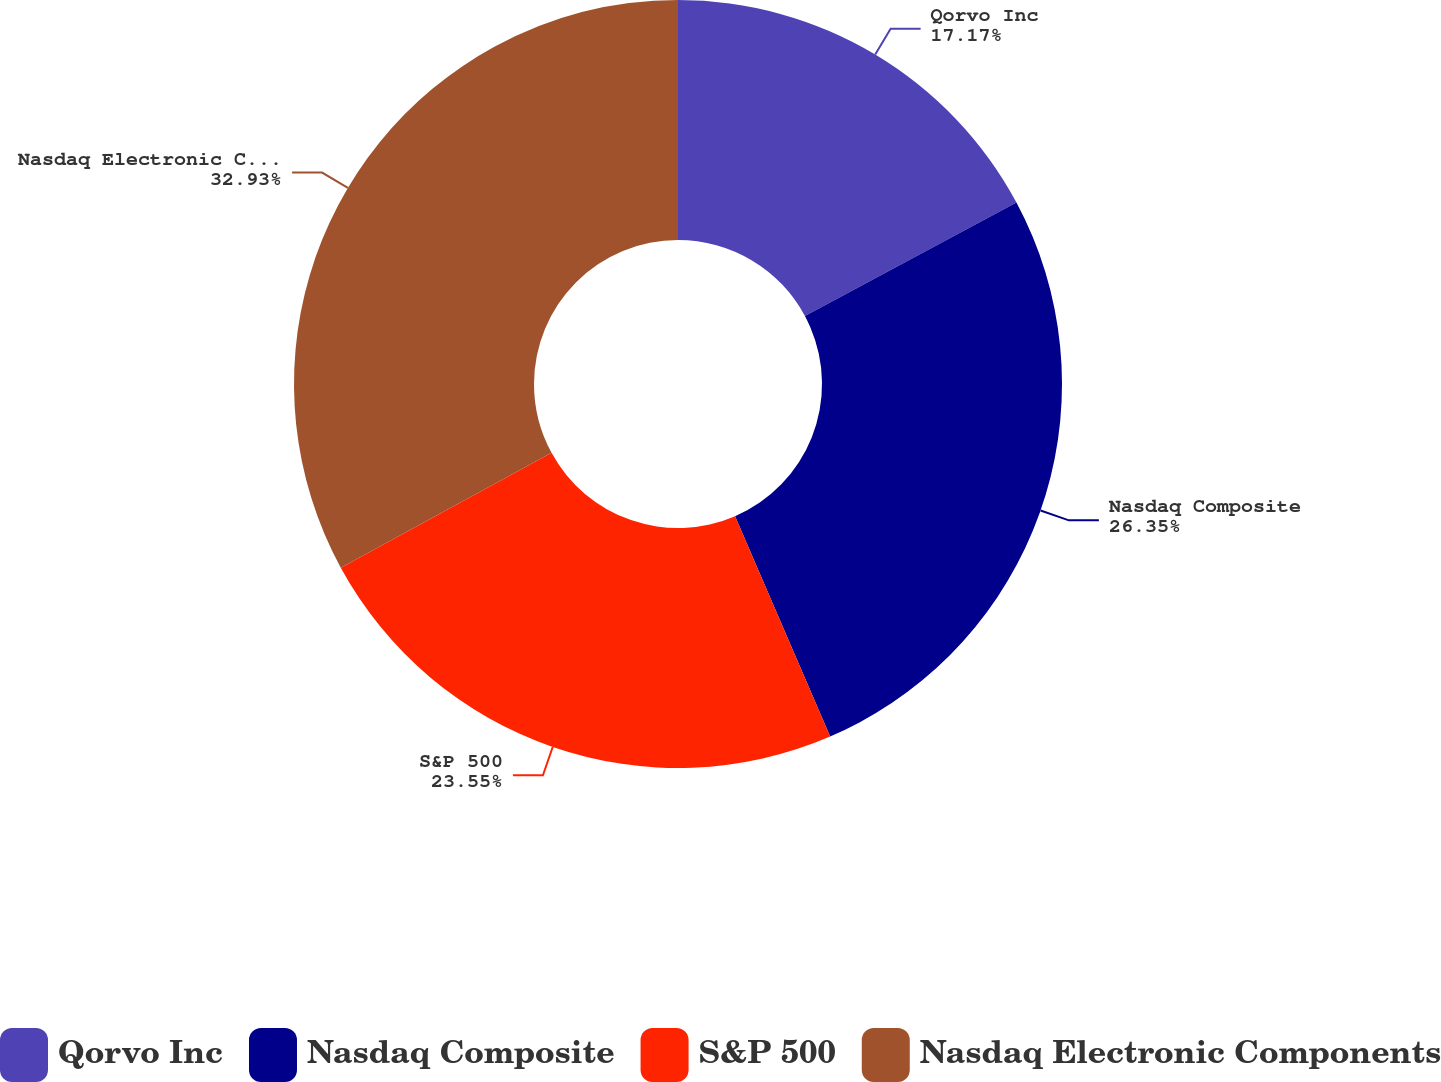Convert chart to OTSL. <chart><loc_0><loc_0><loc_500><loc_500><pie_chart><fcel>Qorvo Inc<fcel>Nasdaq Composite<fcel>S&P 500<fcel>Nasdaq Electronic Components<nl><fcel>17.17%<fcel>26.35%<fcel>23.55%<fcel>32.94%<nl></chart> 